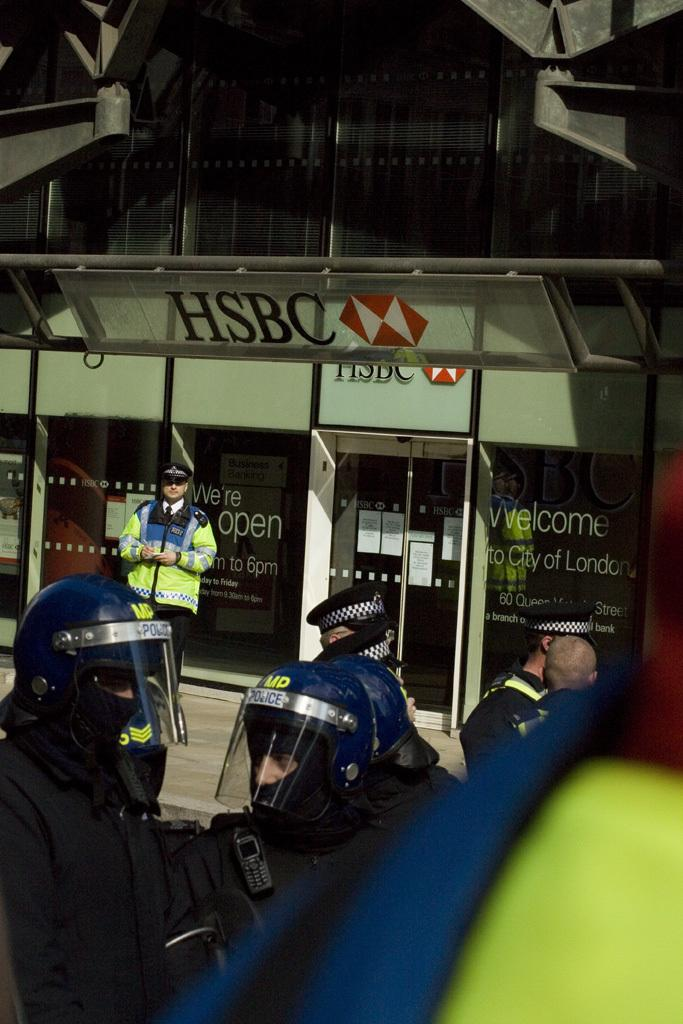Who or what is present at the bottom of the image? There are people at the bottom of the image. What can be seen in the background of the image? There is a building in the background of the image. How many spiders are visible on the building in the image? There are no spiders visible on the building in the image. What type of action are the people at the bottom of the image engaged in? The provided facts do not give any information about the actions of the people in the image. Is there a rat present in the image? There is no mention of a rat in the provided facts, so it cannot be determined if a rat is present in the image. 